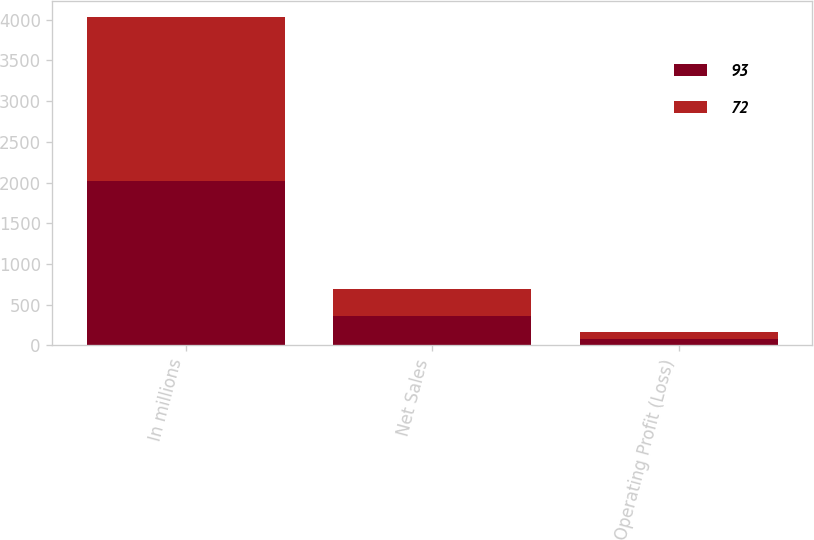<chart> <loc_0><loc_0><loc_500><loc_500><stacked_bar_chart><ecel><fcel>In millions<fcel>Net Sales<fcel>Operating Profit (Loss)<nl><fcel>93<fcel>2018<fcel>359<fcel>72<nl><fcel>72<fcel>2016<fcel>327<fcel>93<nl></chart> 